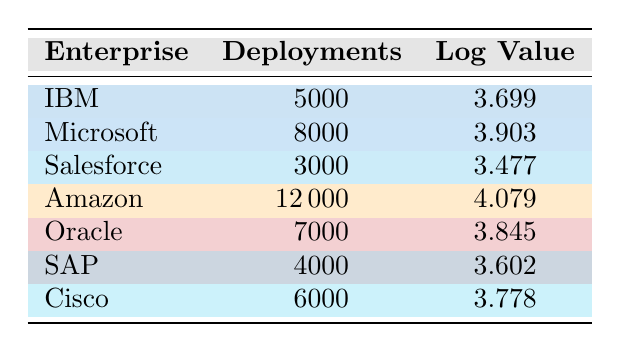What is the highest number of deployments among the enterprises listed? From the table, I see that Amazon has 12000 deployments, which is more than any other enterprise.
Answer: 12000 Which enterprise has the fewest deployments? According to the table, Salesforce has the least number of deployments at 3000.
Answer: 3000 What is the logarithmic value for Oracle? The table shows Oracle has a logarithmic value of 3.845.
Answer: 3.845 Calculate the average number of deployments across all enterprises. First, I sum the deployments: (5000 + 8000 + 3000 + 12000 + 7000 + 4000 + 6000) = 50000. There are 7 enterprises, so the average is 50000 / 7 = 7142.86.
Answer: 7142.86 Is Amazon's logarithmic value greater than Microsoft's? The table indicates Amazon's logarithmic value is 4.079 while Microsoft's is 3.903, so yes, Amazon's value is greater.
Answer: Yes Which enterprise has a logarithmic value closest to 3.7? Comparing all values in the table, IBM has a logarithmic value of 3.699, which is the closest to 3.7.
Answer: IBM How many enterprises have more than 6000 deployments? From the table, I count Amazon (12000), Microsoft (8000), Oracle (7000), and Cisco (6000). That's a total of 4 enterprises.
Answer: 4 What is the difference between the highest and lowest logarithmic values? The highest logarithmic value is 4.079 (Amazon) and the lowest is 3.477 (Salesforce). The difference is 4.079 - 3.477 = 0.602.
Answer: 0.602 Is the average logarithmic value greater than 3.7? First, I sum the logarithmic values: (3.699 + 3.903 + 3.477 + 4.079 + 3.845 + 3.602 + 3.778) = 24.783. Then, dividing by 7 gives an average of approximately 3.54, which is not greater than 3.7.
Answer: No 